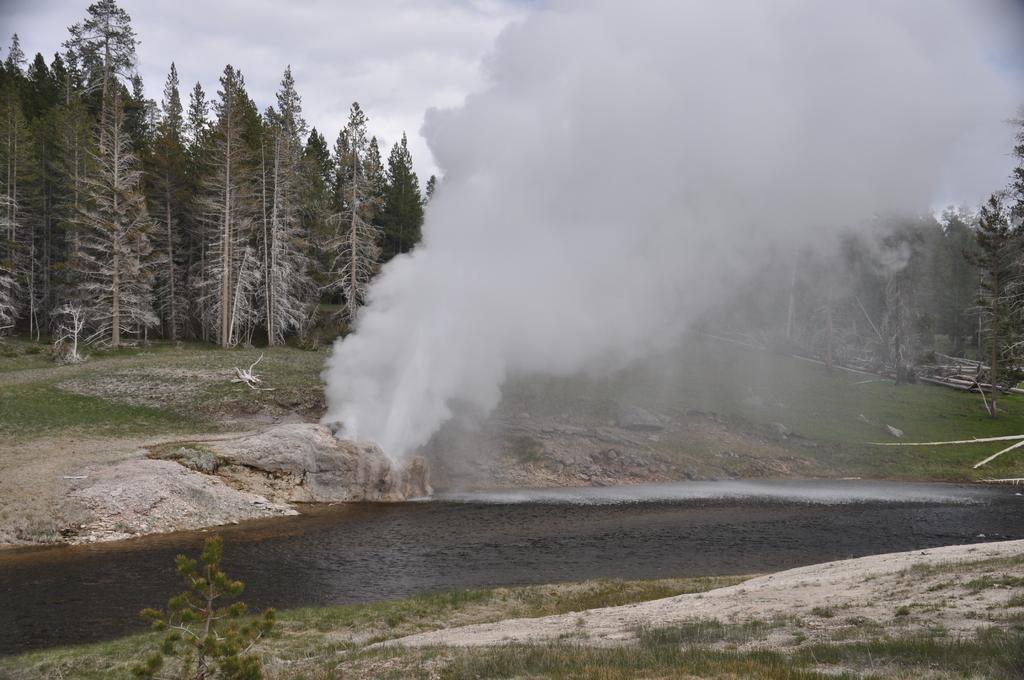Describe this image in one or two sentences. In this picture there is water at the bottom side of the image and there are trees in the background area of the image and there is smoke in the center of the image. 